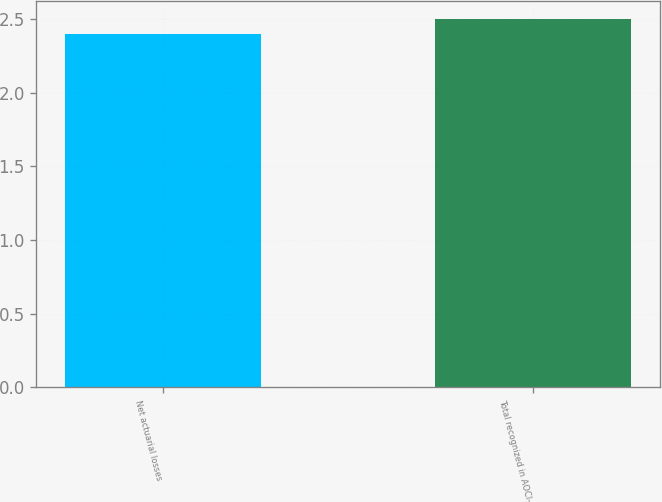Convert chart to OTSL. <chart><loc_0><loc_0><loc_500><loc_500><bar_chart><fcel>Net actuarial losses<fcel>Total recognized in AOCI-<nl><fcel>2.4<fcel>2.5<nl></chart> 